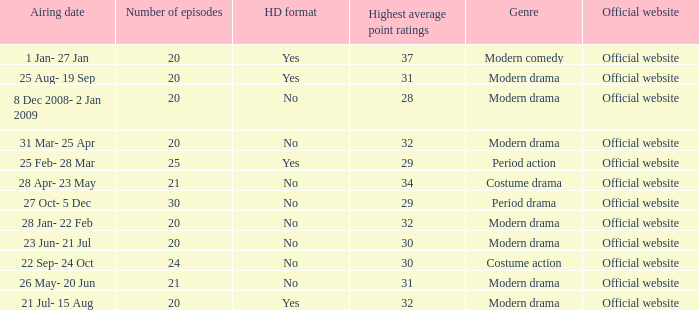What was the airing date when the number of episodes was larger than 20 and had the genre of costume action? 22 Sep- 24 Oct. 